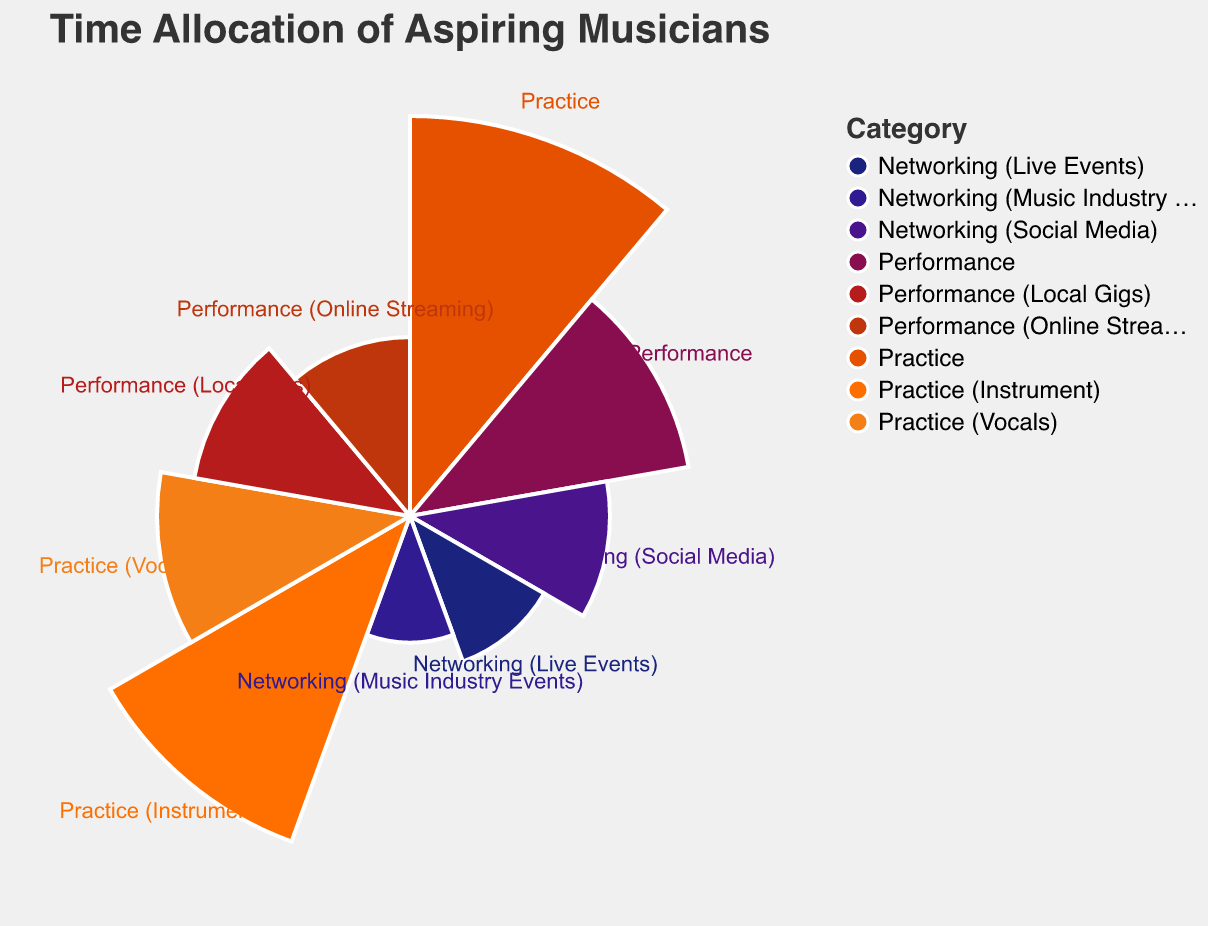What is the total number of hours allocated to Practice activities? To calculate the total hours spent on Practice activities, we need to sum up the hours for "Practice", "Practice (Instrument)", and "Practice (Vocals)". The hours are 20, 15, and 8 respectively. Therefore, the total hours are 20 + 15 + 8 = 43.
Answer: 43 How does the time allocated to Performance compare with Networking (Social Media)? When comparing the two categories, we see that the time allocated to Performance is 10 hours, while Networking (Social Media) has 5 hours. Therefore, Performance has double the hours of Networking (Social Media).
Answer: Performance has double the hours of Networking (Social Media) Which category has the least amount of hours allocated per week? By examining the figure, the category with the least amount of hours allocated is "Networking (Music Industry Events)" with 2 hours per week.
Answer: Networking (Music Industry Events) What is the combined total of hours allocated to all Networking activities? To find the total hours for Networking activities, we sum the hours for "Networking (Social Media)", "Networking (Live Events)", and "Networking (Music Industry Events)". These are 5, 3, and 2 hours respectively. Therefore, the total hours are 5 + 3 + 2 = 10.
Answer: 10 How much more time is spent on Practice than Performance per week? The total time spent on Practice is 20 hours, while Performance has 10 hours. The difference between them is 20 - 10 = 10 hours.
Answer: 10 Which sub-category of Practice has more hours allocated, Instrument or Vocals? By looking at the figure, we see that "Practice (Instrument)" has 15 hours and "Practice (Vocals)" has 8 hours. Therefore, Instrument has more hours allocated.
Answer: Instrument Are there more hours spent on Performance (Local Gigs) or Performance (Online Streaming)? Comparing the two sub-categories, Performance (Local Gigs) has 6 hours, while Performance (Online Streaming) has 4 hours. Hence, more hours are spent on Performance (Local Gigs).
Answer: Performance (Local Gigs) What is the total number of hours allocated to Performance sub-categories per week? The two sub-categories of Performance are "Performance (Local Gigs)" and "Performance (Online Streaming)" with 6 and 4 hours respectively. Adding these together gives us 6 + 4 = 10 hours.
Answer: 10 Which category uses a red color in the visualization? By analyzing the color scheme used in the visualization, "Networking (Music Industry Events)" is associated with a red color.
Answer: Networking (Music Industry Events) What is the overall weekly hour allocation for all categories combined? To get the overall weekly hour allocation, sum up the hours for all categories: 20 (Practice) + 10 (Performance) + 5 (Networking (Social Media)) + 3 (Networking (Live Events)) + 2 (Networking (Music Industry Events)) + 15 (Practice (Instrument)) + 8 (Practice (Vocals)) + 6 (Performance (Local Gigs)) + 4 (Performance (Online Streaming)) = 73 hours.
Answer: 73 